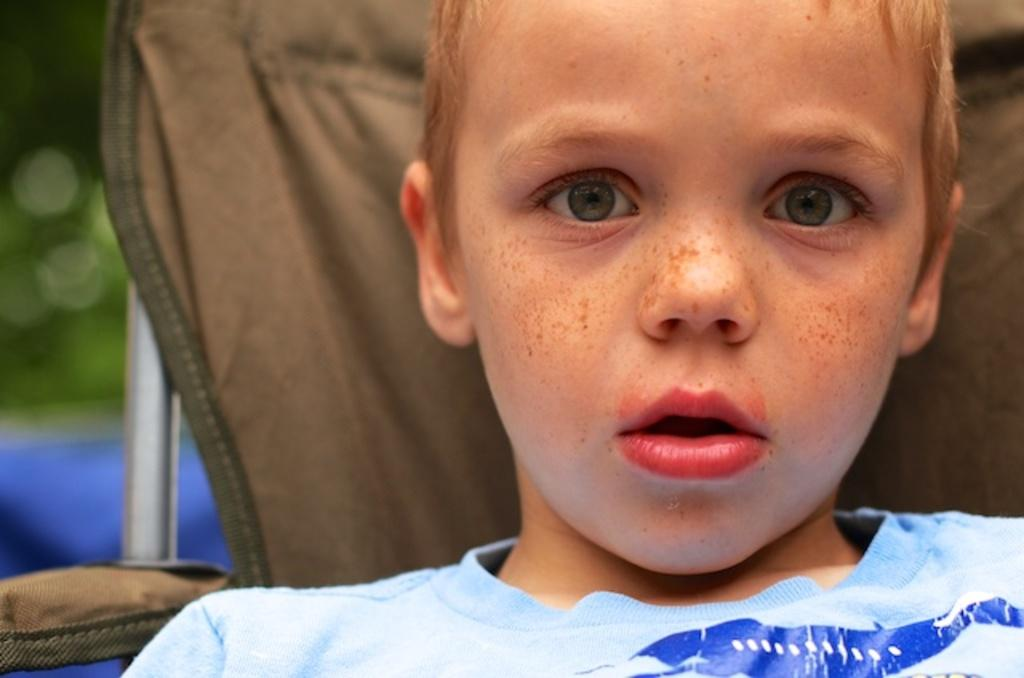Who is the main subject in the image? There is a boy in the image. What is behind the boy in the image? There is a brown color cloth behind the boy. What object can be seen in the image besides the boy and the cloth? There is a rod in the image. What color is the background of the image? The background of the image is green. How many trees are visible in the image? There are no trees visible in the image. What type of vest is the boy wearing in the image? The boy is not wearing a vest in the image. 